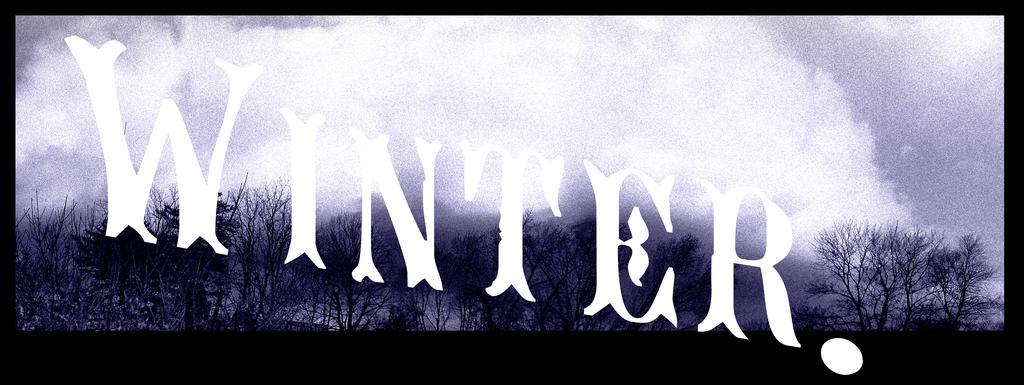Where was the image taken? The image was taken in a theater. What can be seen on the stage in the image? There is a screen visible in the image. What can be seen in the background of the image? Trees and plants are visible in the background of the image. What is visible in the sky in the image? Clouds are visible in the sky. What word is written in the image? The word 'WINTER'WINTER' is written in the image. What type of property does the aunt own in the image? There is no mention of an aunt or any property in the image. What is the stem used for in the image? There is no stem present in the image. 